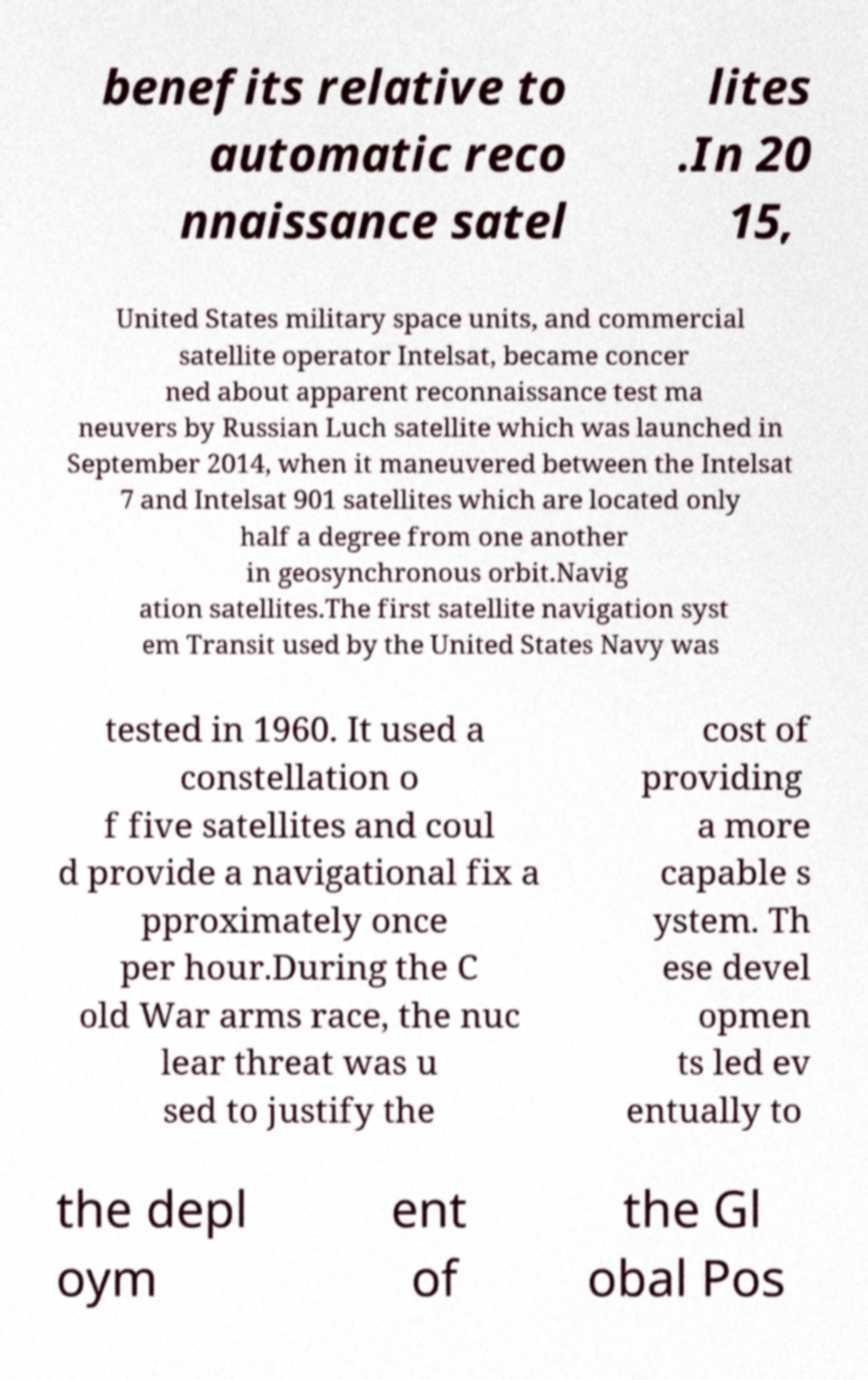Could you assist in decoding the text presented in this image and type it out clearly? benefits relative to automatic reco nnaissance satel lites .In 20 15, United States military space units, and commercial satellite operator Intelsat, became concer ned about apparent reconnaissance test ma neuvers by Russian Luch satellite which was launched in September 2014, when it maneuvered between the Intelsat 7 and Intelsat 901 satellites which are located only half a degree from one another in geosynchronous orbit.Navig ation satellites.The first satellite navigation syst em Transit used by the United States Navy was tested in 1960. It used a constellation o f five satellites and coul d provide a navigational fix a pproximately once per hour.During the C old War arms race, the nuc lear threat was u sed to justify the cost of providing a more capable s ystem. Th ese devel opmen ts led ev entually to the depl oym ent of the Gl obal Pos 